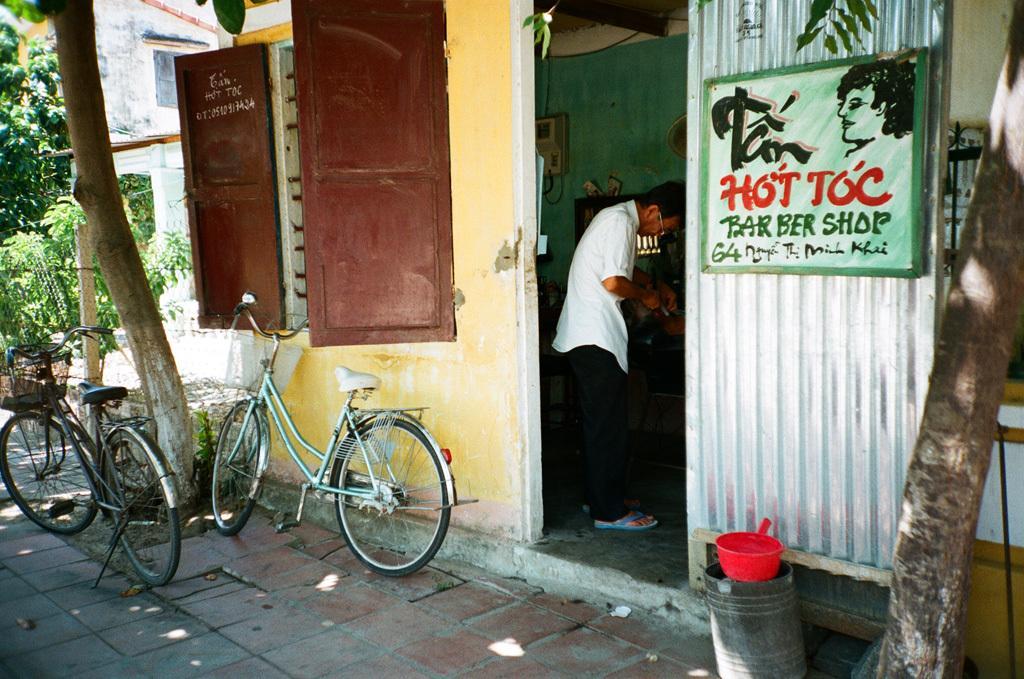Please provide a concise description of this image. In the picture I can see bicycles parked here, I can see trees, windows on the left side of the image. Here I can see a bucket, red color object, a person wearing the white color shirt is standing here and I can see a board on the left side of the image. 